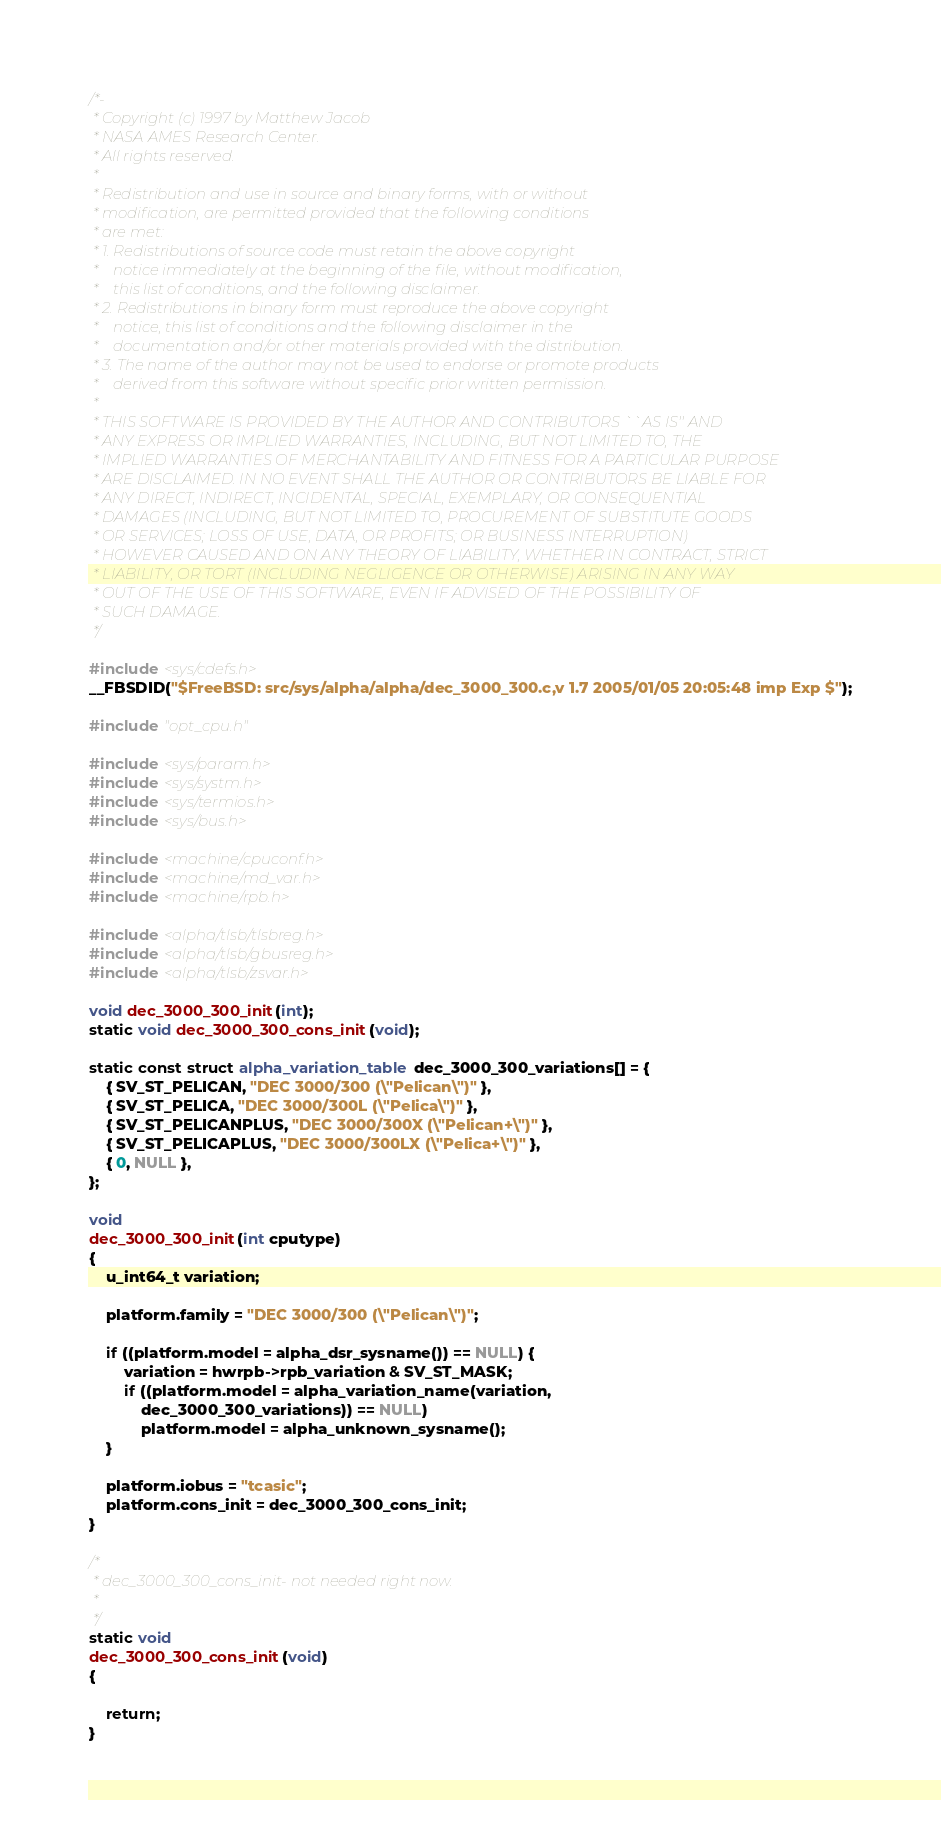Convert code to text. <code><loc_0><loc_0><loc_500><loc_500><_C_>/*-
 * Copyright (c) 1997 by Matthew Jacob
 * NASA AMES Research Center.
 * All rights reserved.
 *
 * Redistribution and use in source and binary forms, with or without
 * modification, are permitted provided that the following conditions
 * are met:
 * 1. Redistributions of source code must retain the above copyright
 *    notice immediately at the beginning of the file, without modification,
 *    this list of conditions, and the following disclaimer.
 * 2. Redistributions in binary form must reproduce the above copyright
 *    notice, this list of conditions and the following disclaimer in the
 *    documentation and/or other materials provided with the distribution.
 * 3. The name of the author may not be used to endorse or promote products
 *    derived from this software without specific prior written permission.
 *
 * THIS SOFTWARE IS PROVIDED BY THE AUTHOR AND CONTRIBUTORS ``AS IS'' AND
 * ANY EXPRESS OR IMPLIED WARRANTIES, INCLUDING, BUT NOT LIMITED TO, THE
 * IMPLIED WARRANTIES OF MERCHANTABILITY AND FITNESS FOR A PARTICULAR PURPOSE
 * ARE DISCLAIMED. IN NO EVENT SHALL THE AUTHOR OR CONTRIBUTORS BE LIABLE FOR
 * ANY DIRECT, INDIRECT, INCIDENTAL, SPECIAL, EXEMPLARY, OR CONSEQUENTIAL
 * DAMAGES (INCLUDING, BUT NOT LIMITED TO, PROCUREMENT OF SUBSTITUTE GOODS
 * OR SERVICES; LOSS OF USE, DATA, OR PROFITS; OR BUSINESS INTERRUPTION)
 * HOWEVER CAUSED AND ON ANY THEORY OF LIABILITY, WHETHER IN CONTRACT, STRICT
 * LIABILITY, OR TORT (INCLUDING NEGLIGENCE OR OTHERWISE) ARISING IN ANY WAY
 * OUT OF THE USE OF THIS SOFTWARE, EVEN IF ADVISED OF THE POSSIBILITY OF
 * SUCH DAMAGE.
 */

#include <sys/cdefs.h>
__FBSDID("$FreeBSD: src/sys/alpha/alpha/dec_3000_300.c,v 1.7 2005/01/05 20:05:48 imp Exp $");

#include "opt_cpu.h"

#include <sys/param.h>
#include <sys/systm.h>
#include <sys/termios.h>
#include <sys/bus.h>

#include <machine/cpuconf.h>
#include <machine/md_var.h>
#include <machine/rpb.h>

#include <alpha/tlsb/tlsbreg.h>
#include <alpha/tlsb/gbusreg.h>
#include <alpha/tlsb/zsvar.h>

void dec_3000_300_init(int);
static void dec_3000_300_cons_init(void);

static const struct alpha_variation_table dec_3000_300_variations[] = {
	{ SV_ST_PELICAN, "DEC 3000/300 (\"Pelican\")" },
	{ SV_ST_PELICA, "DEC 3000/300L (\"Pelica\")" },
	{ SV_ST_PELICANPLUS, "DEC 3000/300X (\"Pelican+\")" },
	{ SV_ST_PELICAPLUS, "DEC 3000/300LX (\"Pelica+\")" },
	{ 0, NULL },
};

void
dec_3000_300_init(int cputype)
{
	u_int64_t variation;

	platform.family = "DEC 3000/300 (\"Pelican\")";

	if ((platform.model = alpha_dsr_sysname()) == NULL) {
		variation = hwrpb->rpb_variation & SV_ST_MASK;
		if ((platform.model = alpha_variation_name(variation,
		    dec_3000_300_variations)) == NULL)
			platform.model = alpha_unknown_sysname();
	}

	platform.iobus = "tcasic";
	platform.cons_init = dec_3000_300_cons_init;
}

/*
 * dec_3000_300_cons_init- not needed right now.
 *
 */
static void
dec_3000_300_cons_init(void)
{

	return;
}
</code> 